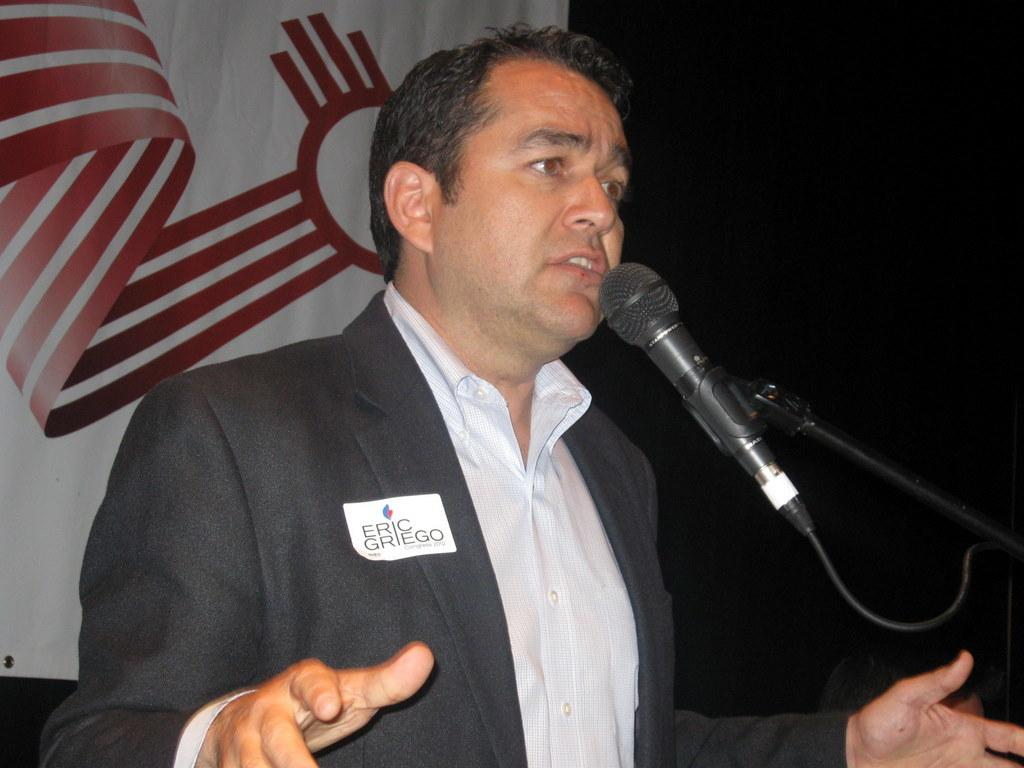What is happening on the stage in the image? There is a person on the stage in the image. What can be seen near the person on the stage? There is a microphone on a stand in the image. What else is visible in the image besides the person and microphone? There is a poster with an image in the image. How many snakes are slithering around the person on stage in the image? There are no snakes present in the image; it only features a person, a microphone, and a poster. What type of reward is the person on stage receiving for their performance in the image? There is no indication of a reward in the image; it only shows a person, a microphone, and a poster. 